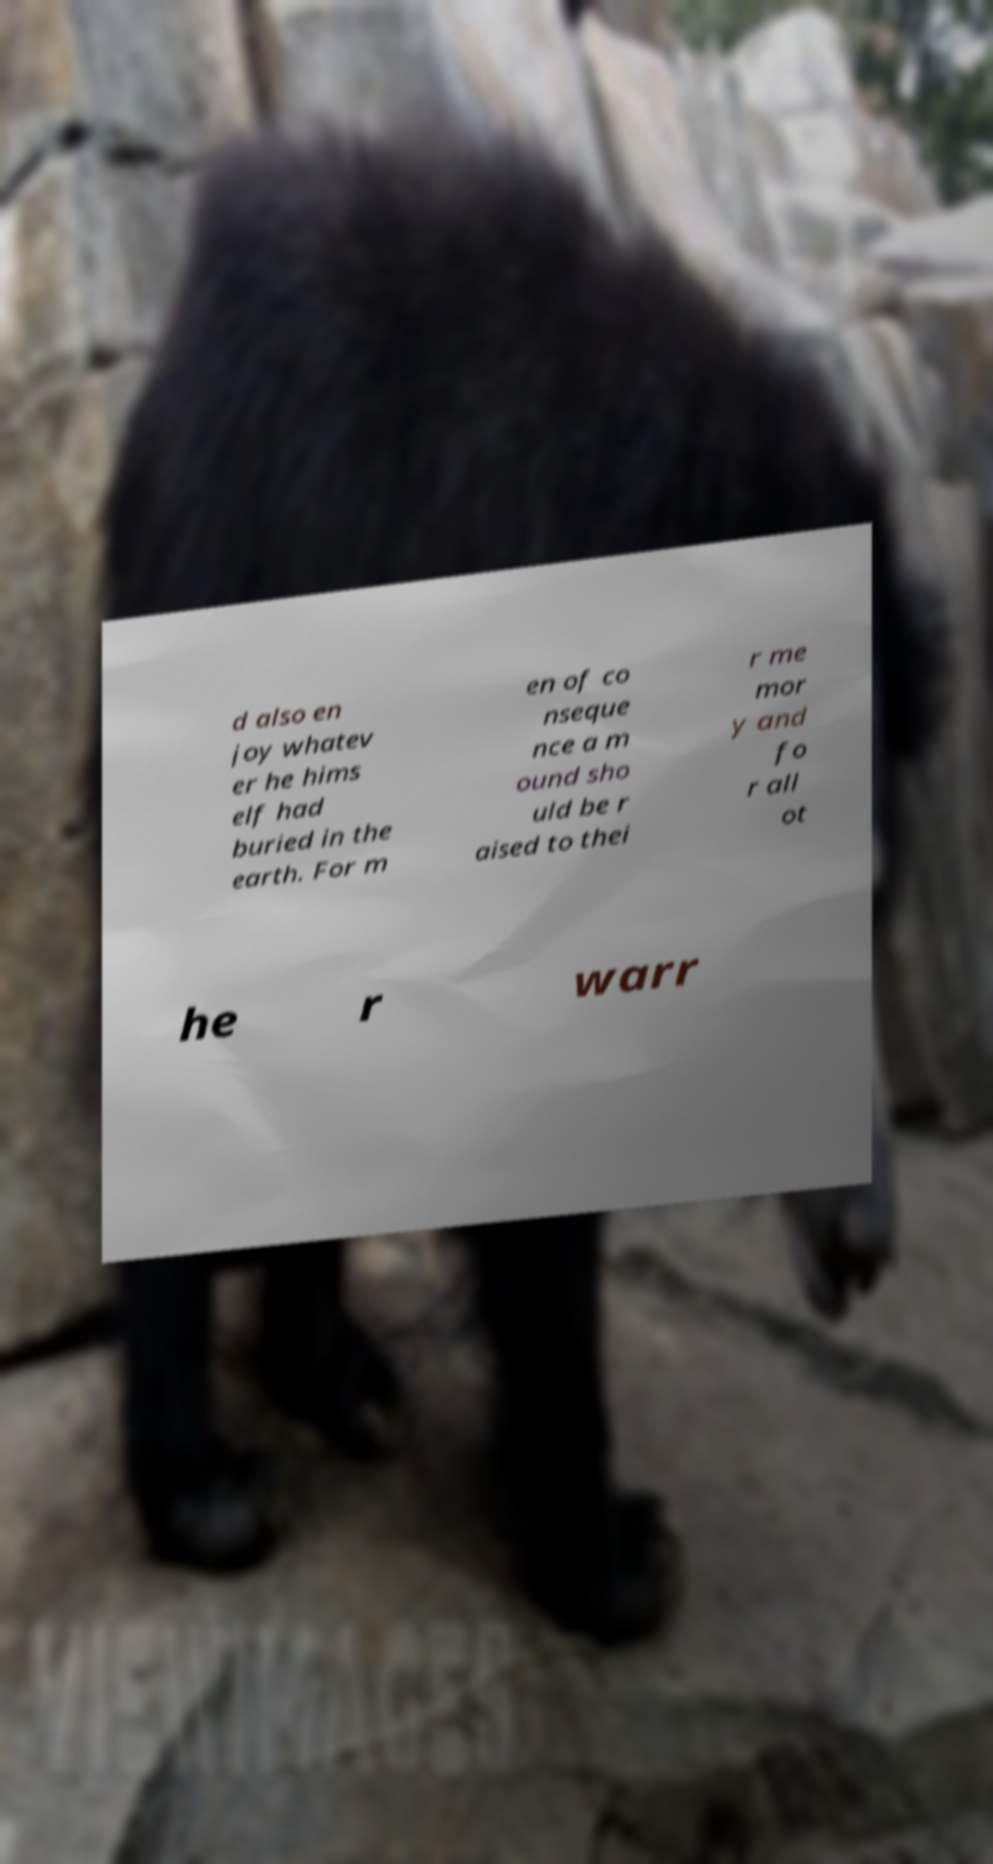There's text embedded in this image that I need extracted. Can you transcribe it verbatim? d also en joy whatev er he hims elf had buried in the earth. For m en of co nseque nce a m ound sho uld be r aised to thei r me mor y and fo r all ot he r warr 